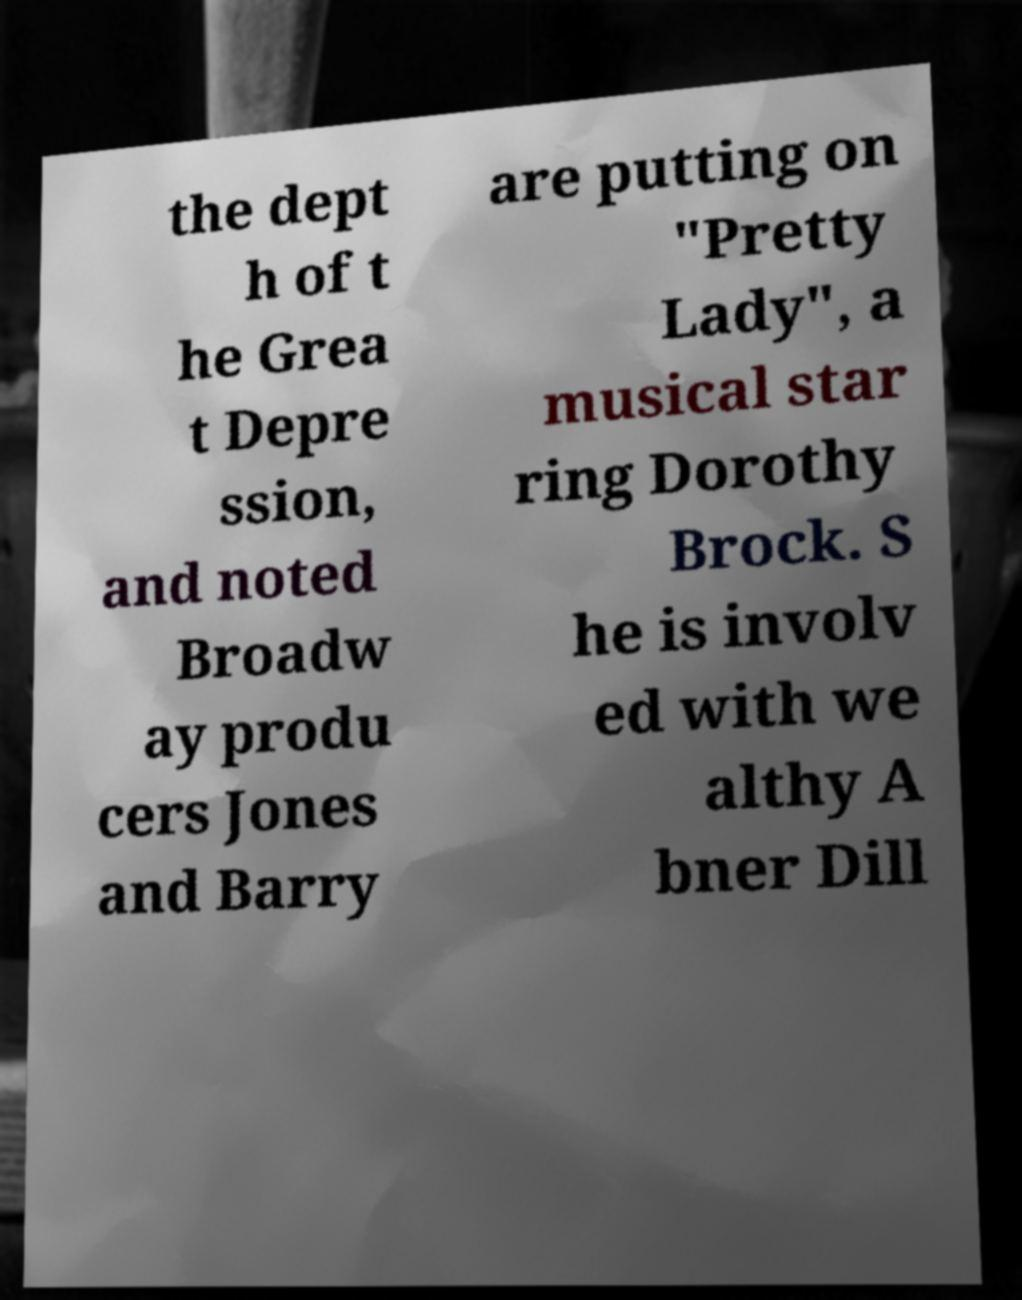Can you accurately transcribe the text from the provided image for me? the dept h of t he Grea t Depre ssion, and noted Broadw ay produ cers Jones and Barry are putting on "Pretty Lady", a musical star ring Dorothy Brock. S he is involv ed with we althy A bner Dill 